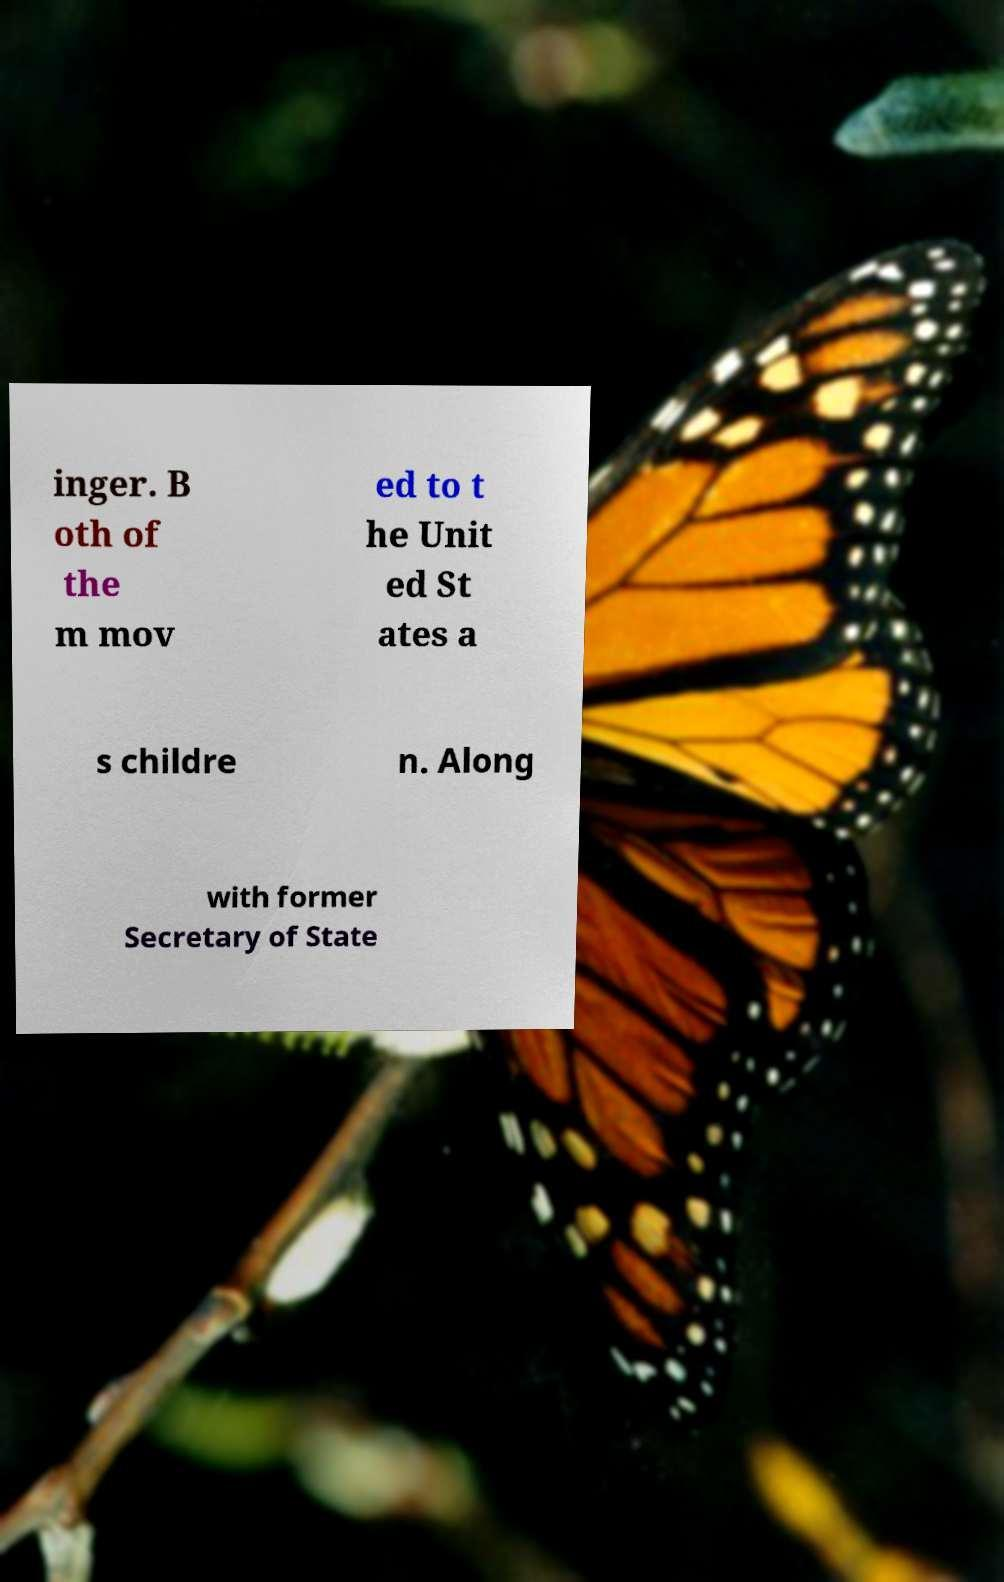There's text embedded in this image that I need extracted. Can you transcribe it verbatim? inger. B oth of the m mov ed to t he Unit ed St ates a s childre n. Along with former Secretary of State 